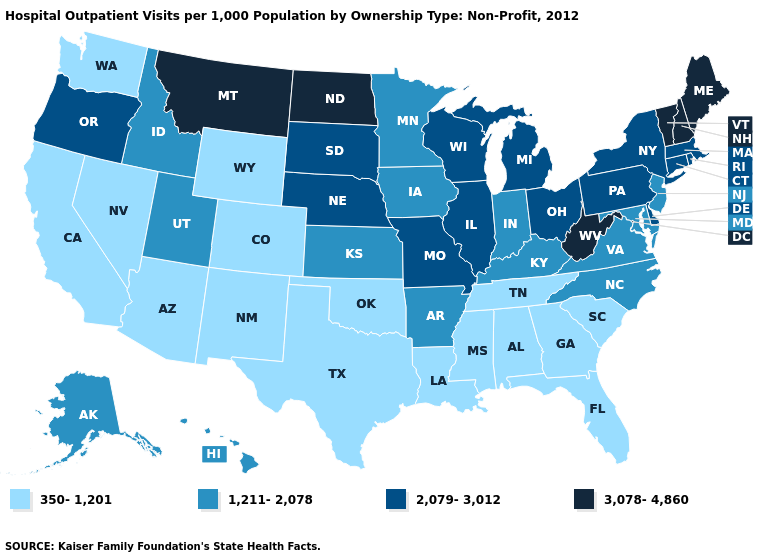Name the states that have a value in the range 2,079-3,012?
Be succinct. Connecticut, Delaware, Illinois, Massachusetts, Michigan, Missouri, Nebraska, New York, Ohio, Oregon, Pennsylvania, Rhode Island, South Dakota, Wisconsin. What is the lowest value in the South?
Answer briefly. 350-1,201. What is the lowest value in the USA?
Keep it brief. 350-1,201. What is the highest value in states that border Arkansas?
Short answer required. 2,079-3,012. What is the highest value in the USA?
Write a very short answer. 3,078-4,860. What is the highest value in states that border North Carolina?
Quick response, please. 1,211-2,078. Name the states that have a value in the range 350-1,201?
Quick response, please. Alabama, Arizona, California, Colorado, Florida, Georgia, Louisiana, Mississippi, Nevada, New Mexico, Oklahoma, South Carolina, Tennessee, Texas, Washington, Wyoming. Does Connecticut have the highest value in the USA?
Write a very short answer. No. What is the value of Nevada?
Write a very short answer. 350-1,201. What is the highest value in the South ?
Give a very brief answer. 3,078-4,860. How many symbols are there in the legend?
Give a very brief answer. 4. Which states have the lowest value in the USA?
Give a very brief answer. Alabama, Arizona, California, Colorado, Florida, Georgia, Louisiana, Mississippi, Nevada, New Mexico, Oklahoma, South Carolina, Tennessee, Texas, Washington, Wyoming. Among the states that border New Mexico , does Utah have the lowest value?
Quick response, please. No. Does Delaware have the lowest value in the USA?
Keep it brief. No. Does South Dakota have the same value as Pennsylvania?
Short answer required. Yes. 